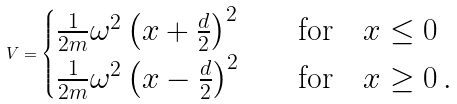Convert formula to latex. <formula><loc_0><loc_0><loc_500><loc_500>V = \begin{cases} \frac { 1 } { 2 m } \omega ^ { 2 } \left ( x + \frac { d } { 2 } \right ) ^ { 2 } & \quad \text {for} \quad x \leq 0 \\ \frac { 1 } { 2 m } \omega ^ { 2 } \left ( x - \frac { d } { 2 } \right ) ^ { 2 } & \quad \text {for} \quad x \geq 0 \, . \end{cases}</formula> 